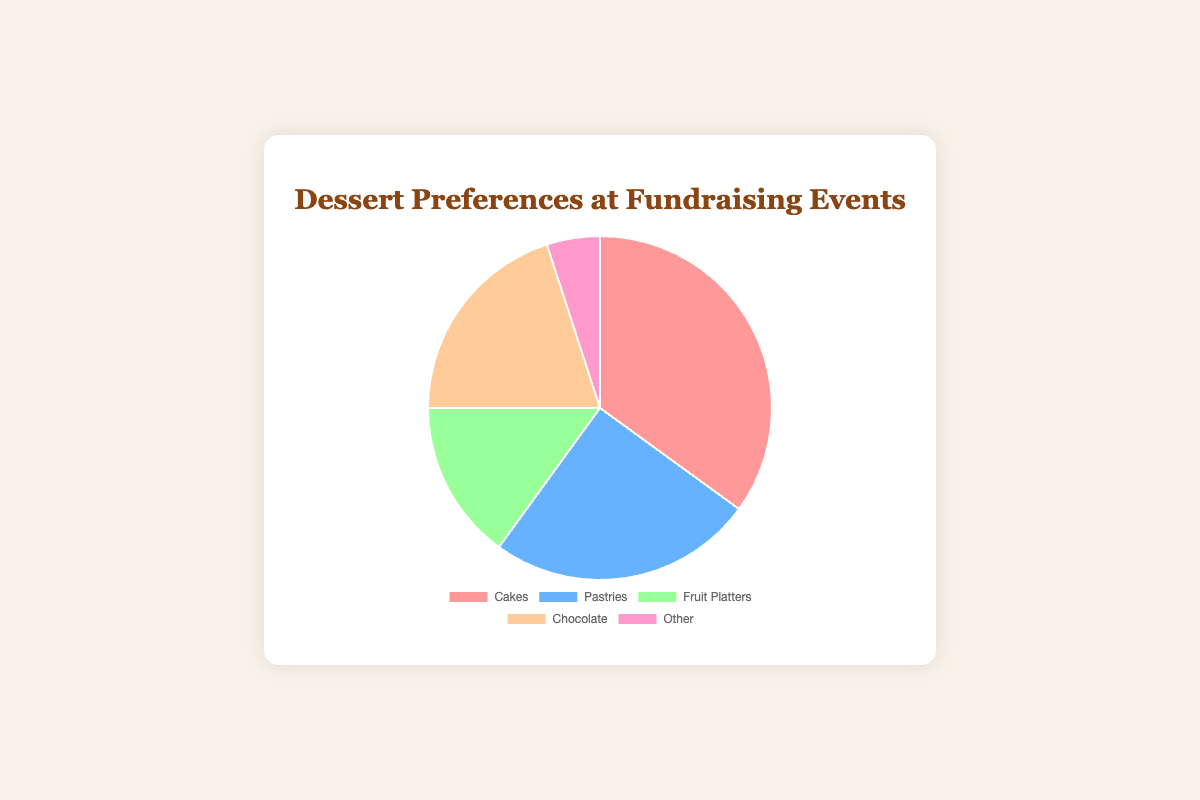What percentage of people prefer cakes over chocolate? To find the percentage difference, subtract the percentage of those who prefer chocolate (20%) from those who prefer cakes (35%). 35% - 20% = 15%
Answer: 15% Which dessert type is the least preferred? The dessert type with the smallest percentage is "Other," which has 5%.
Answer: Other What is the combined percentage of people who prefer cakes and pastries? Add the percentages of those who prefer cakes (35%) and those who prefer pastries (25%). 35% + 25% = 60%
Answer: 60% How many more people prefer cakes than fruit platters? Subtract the percentage of those who prefer fruit platters (15%) from those who prefer cakes (35%). 35% - 15% = 20%
Answer: 20% If you were to combine the preferences for fruit platters and chocolate, would it exceed the preference for cakes? Add the percentages of fruit platters (15%) and chocolate (20%), and compare the result to the percentage for cakes (35%). 15% + 20% = 35%, which is equal to the percentage for cakes.
Answer: No Which dessert type has the second highest preference? The dessert type with the highest preference is cakes (35%), and the type with the next highest preference is pastries (25%).
Answer: Pastries If the percentage of people who prefer pastries increased by 10%, what would be the new percentage, and where would pastries rank in terms of preference? Add 10% to the current percentage for pastries (25%). The new percentage would be 25% + 10% = 35%. Pastries would then tie with cakes for the top rank.
Answer: 35%, tied for first What is the total percentage of preferences for non-fruit desserts? Add the percentages of cakes (35%), pastries (25%), chocolate (20%), and other (5%). 35% + 25% + 20% + 5% = 85%
Answer: 85% Which dessert type has a visual segment colored in blue? Referring to the colors provided, pastries have a segment colored in blue.
Answer: Pastries Are there more people who prefer chocolate than fruit platters? Compare the percentages for chocolate (20%) and fruit platters (15%). Chocolate has a higher percentage (20% vs 15%).
Answer: Yes 